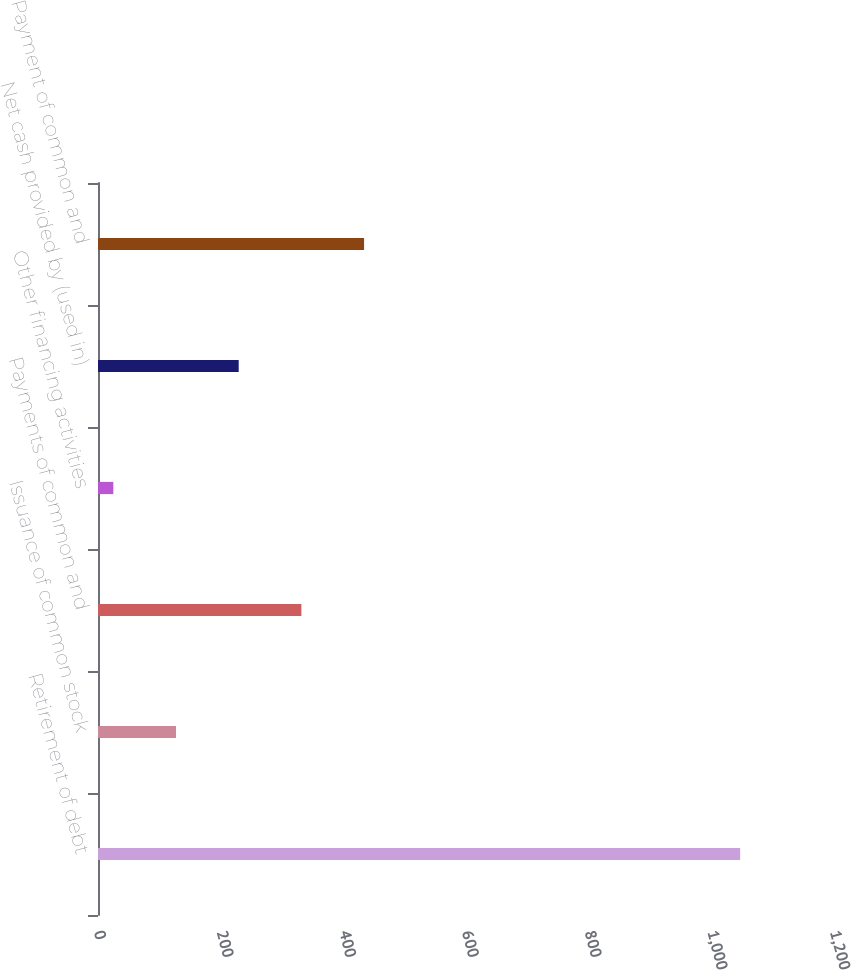<chart> <loc_0><loc_0><loc_500><loc_500><bar_chart><fcel>Retirement of debt<fcel>Issuance of common stock<fcel>Payments of common and<fcel>Other financing activities<fcel>Net cash provided by (used in)<fcel>Payment of common and<nl><fcel>1047<fcel>127.2<fcel>331.6<fcel>25<fcel>229.4<fcel>433.8<nl></chart> 